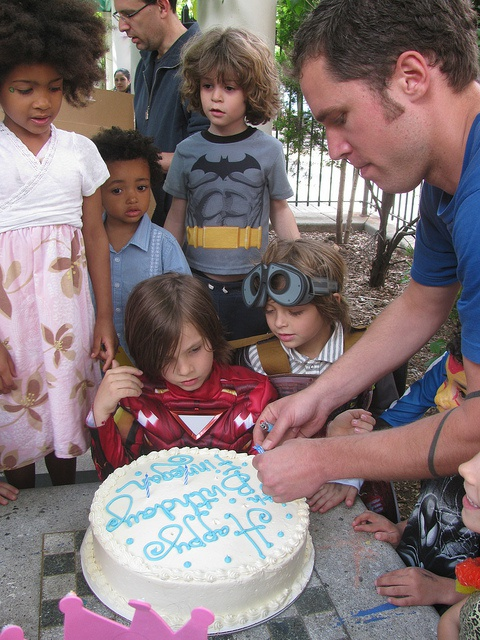Describe the objects in this image and their specific colors. I can see people in black, brown, and lightpink tones, people in black, lavender, brown, and darkgray tones, cake in black, lightgray, lightblue, and darkgray tones, people in black, gray, and maroon tones, and people in black, maroon, brown, and gray tones in this image. 